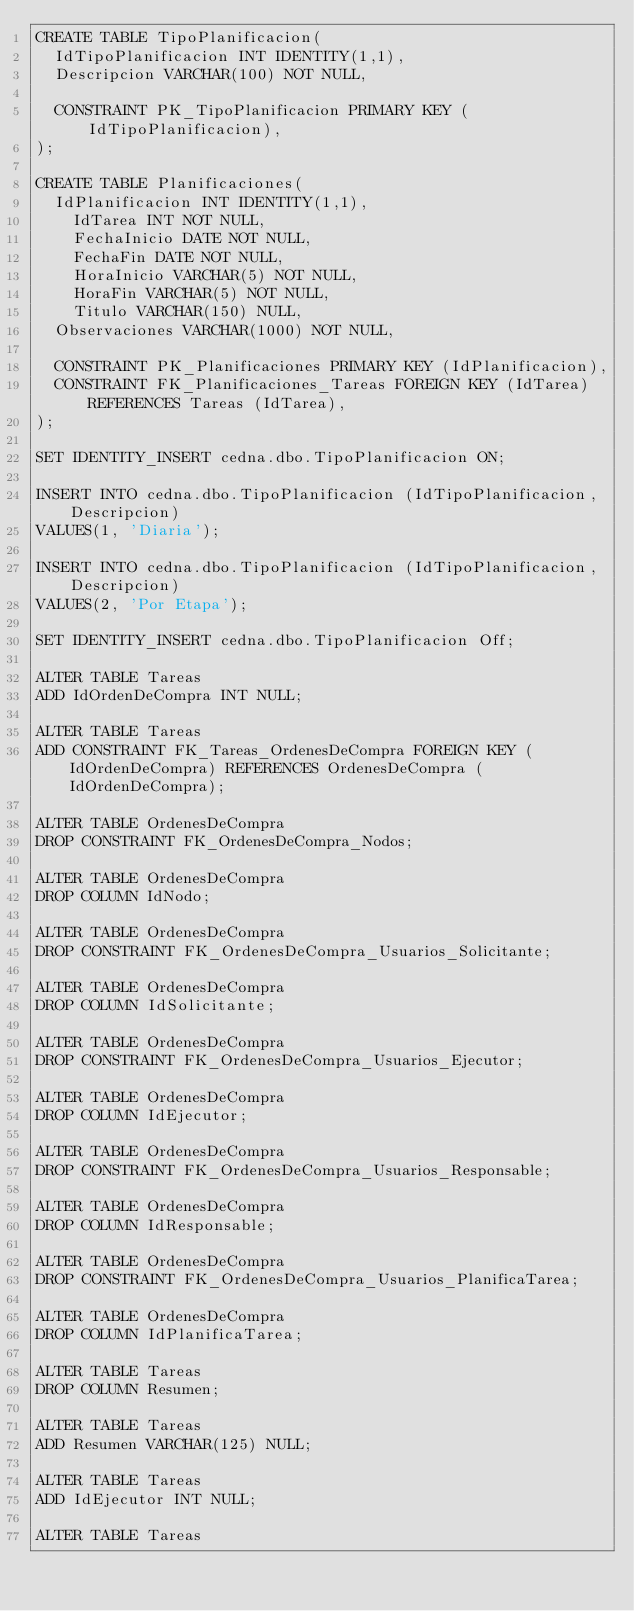Convert code to text. <code><loc_0><loc_0><loc_500><loc_500><_SQL_>CREATE TABLE TipoPlanificacion(
	IdTipoPlanificacion INT IDENTITY(1,1),
	Descripcion VARCHAR(100) NOT NULL,

	CONSTRAINT PK_TipoPlanificacion PRIMARY KEY (IdTipoPlanificacion),   
);

CREATE TABLE Planificaciones(
	IdPlanificacion INT IDENTITY(1,1),
    IdTarea INT NOT NULL,
    FechaInicio DATE NOT NULL,
    FechaFin DATE NOT NULL,
    HoraInicio VARCHAR(5) NOT NULL,
    HoraFin VARCHAR(5) NOT NULL,
    Titulo VARCHAR(150) NULL,
	Observaciones VARCHAR(1000) NOT NULL,

	CONSTRAINT PK_Planificaciones PRIMARY KEY (IdPlanificacion),  
	CONSTRAINT FK_Planificaciones_Tareas FOREIGN KEY (IdTarea) REFERENCES Tareas (IdTarea), 
);

SET IDENTITY_INSERT cedna.dbo.TipoPlanificacion ON;

INSERT INTO cedna.dbo.TipoPlanificacion (IdTipoPlanificacion, Descripcion)
VALUES(1, 'Diaria');

INSERT INTO cedna.dbo.TipoPlanificacion (IdTipoPlanificacion, Descripcion)
VALUES(2, 'Por Etapa');

SET IDENTITY_INSERT cedna.dbo.TipoPlanificacion Off;

ALTER TABLE Tareas
ADD IdOrdenDeCompra INT NULL;

ALTER TABLE Tareas
ADD CONSTRAINT FK_Tareas_OrdenesDeCompra FOREIGN KEY (IdOrdenDeCompra) REFERENCES OrdenesDeCompra (IdOrdenDeCompra);

ALTER TABLE OrdenesDeCompra
DROP CONSTRAINT FK_OrdenesDeCompra_Nodos;

ALTER TABLE OrdenesDeCompra
DROP COLUMN IdNodo;

ALTER TABLE OrdenesDeCompra
DROP CONSTRAINT FK_OrdenesDeCompra_Usuarios_Solicitante;

ALTER TABLE OrdenesDeCompra
DROP COLUMN IdSolicitante;

ALTER TABLE OrdenesDeCompra
DROP CONSTRAINT FK_OrdenesDeCompra_Usuarios_Ejecutor;

ALTER TABLE OrdenesDeCompra
DROP COLUMN IdEjecutor;

ALTER TABLE OrdenesDeCompra
DROP CONSTRAINT FK_OrdenesDeCompra_Usuarios_Responsable;

ALTER TABLE OrdenesDeCompra
DROP COLUMN IdResponsable;

ALTER TABLE OrdenesDeCompra
DROP CONSTRAINT FK_OrdenesDeCompra_Usuarios_PlanificaTarea;

ALTER TABLE OrdenesDeCompra
DROP COLUMN IdPlanificaTarea;

ALTER TABLE Tareas
DROP COLUMN Resumen;

ALTER TABLE Tareas
ADD Resumen VARCHAR(125) NULL;

ALTER TABLE Tareas
ADD IdEjecutor INT NULL;

ALTER TABLE Tareas</code> 